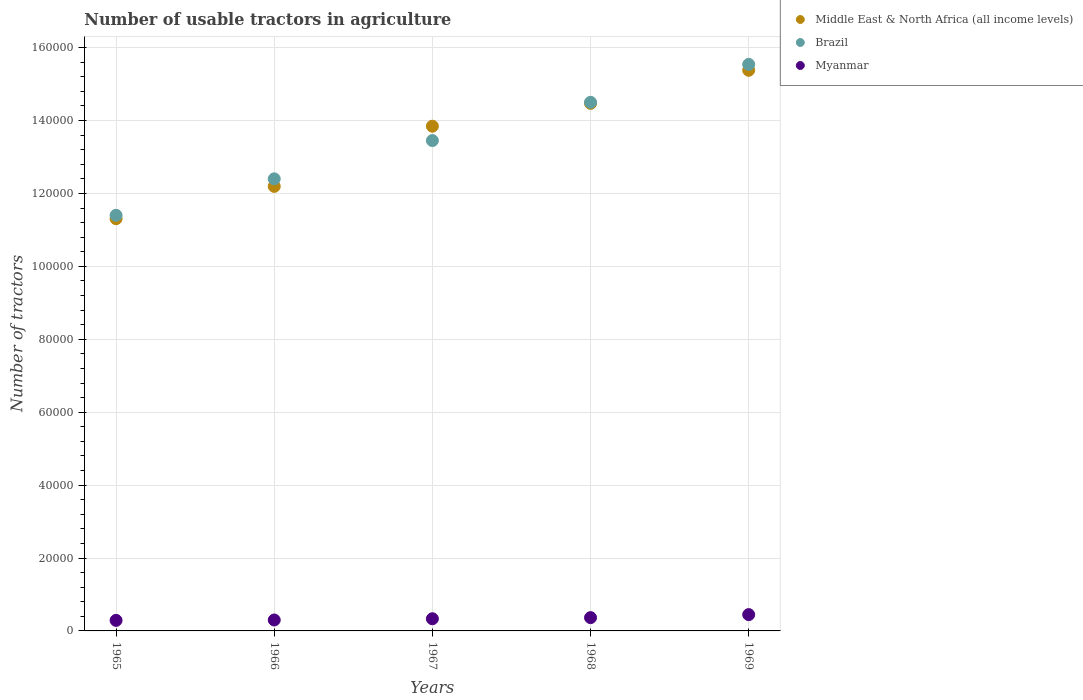What is the number of usable tractors in agriculture in Middle East & North Africa (all income levels) in 1965?
Give a very brief answer. 1.13e+05. Across all years, what is the maximum number of usable tractors in agriculture in Myanmar?
Provide a short and direct response. 4473. Across all years, what is the minimum number of usable tractors in agriculture in Brazil?
Your answer should be compact. 1.14e+05. In which year was the number of usable tractors in agriculture in Brazil maximum?
Make the answer very short. 1969. In which year was the number of usable tractors in agriculture in Middle East & North Africa (all income levels) minimum?
Offer a very short reply. 1965. What is the total number of usable tractors in agriculture in Myanmar in the graph?
Give a very brief answer. 1.73e+04. What is the difference between the number of usable tractors in agriculture in Myanmar in 1966 and that in 1967?
Your response must be concise. -339. What is the difference between the number of usable tractors in agriculture in Brazil in 1969 and the number of usable tractors in agriculture in Middle East & North Africa (all income levels) in 1968?
Ensure brevity in your answer.  1.07e+04. What is the average number of usable tractors in agriculture in Myanmar per year?
Provide a succinct answer. 3469.4. In the year 1968, what is the difference between the number of usable tractors in agriculture in Brazil and number of usable tractors in agriculture in Myanmar?
Provide a succinct answer. 1.41e+05. What is the ratio of the number of usable tractors in agriculture in Brazil in 1966 to that in 1969?
Give a very brief answer. 0.8. Is the number of usable tractors in agriculture in Myanmar in 1965 less than that in 1967?
Make the answer very short. Yes. What is the difference between the highest and the second highest number of usable tractors in agriculture in Brazil?
Your response must be concise. 1.04e+04. What is the difference between the highest and the lowest number of usable tractors in agriculture in Middle East & North Africa (all income levels)?
Keep it short and to the point. 4.07e+04. In how many years, is the number of usable tractors in agriculture in Myanmar greater than the average number of usable tractors in agriculture in Myanmar taken over all years?
Offer a very short reply. 2. Is the sum of the number of usable tractors in agriculture in Brazil in 1967 and 1968 greater than the maximum number of usable tractors in agriculture in Middle East & North Africa (all income levels) across all years?
Provide a succinct answer. Yes. Is the number of usable tractors in agriculture in Myanmar strictly less than the number of usable tractors in agriculture in Middle East & North Africa (all income levels) over the years?
Provide a succinct answer. Yes. How many dotlines are there?
Your answer should be very brief. 3. What is the difference between two consecutive major ticks on the Y-axis?
Keep it short and to the point. 2.00e+04. Does the graph contain any zero values?
Your response must be concise. No. Does the graph contain grids?
Provide a short and direct response. Yes. Where does the legend appear in the graph?
Offer a terse response. Top right. How many legend labels are there?
Your answer should be compact. 3. How are the legend labels stacked?
Offer a very short reply. Vertical. What is the title of the graph?
Make the answer very short. Number of usable tractors in agriculture. What is the label or title of the Y-axis?
Your response must be concise. Number of tractors. What is the Number of tractors in Middle East & North Africa (all income levels) in 1965?
Offer a terse response. 1.13e+05. What is the Number of tractors in Brazil in 1965?
Provide a short and direct response. 1.14e+05. What is the Number of tractors of Myanmar in 1965?
Keep it short and to the point. 2891. What is the Number of tractors of Middle East & North Africa (all income levels) in 1966?
Offer a very short reply. 1.22e+05. What is the Number of tractors of Brazil in 1966?
Your answer should be compact. 1.24e+05. What is the Number of tractors in Myanmar in 1966?
Provide a short and direct response. 3000. What is the Number of tractors of Middle East & North Africa (all income levels) in 1967?
Provide a succinct answer. 1.38e+05. What is the Number of tractors of Brazil in 1967?
Keep it short and to the point. 1.34e+05. What is the Number of tractors in Myanmar in 1967?
Your response must be concise. 3339. What is the Number of tractors of Middle East & North Africa (all income levels) in 1968?
Ensure brevity in your answer.  1.45e+05. What is the Number of tractors in Brazil in 1968?
Make the answer very short. 1.45e+05. What is the Number of tractors of Myanmar in 1968?
Make the answer very short. 3644. What is the Number of tractors in Middle East & North Africa (all income levels) in 1969?
Offer a terse response. 1.54e+05. What is the Number of tractors of Brazil in 1969?
Provide a short and direct response. 1.55e+05. What is the Number of tractors of Myanmar in 1969?
Your answer should be compact. 4473. Across all years, what is the maximum Number of tractors of Middle East & North Africa (all income levels)?
Make the answer very short. 1.54e+05. Across all years, what is the maximum Number of tractors in Brazil?
Offer a very short reply. 1.55e+05. Across all years, what is the maximum Number of tractors in Myanmar?
Offer a very short reply. 4473. Across all years, what is the minimum Number of tractors in Middle East & North Africa (all income levels)?
Give a very brief answer. 1.13e+05. Across all years, what is the minimum Number of tractors of Brazil?
Your answer should be very brief. 1.14e+05. Across all years, what is the minimum Number of tractors in Myanmar?
Keep it short and to the point. 2891. What is the total Number of tractors of Middle East & North Africa (all income levels) in the graph?
Offer a very short reply. 6.72e+05. What is the total Number of tractors in Brazil in the graph?
Provide a succinct answer. 6.73e+05. What is the total Number of tractors of Myanmar in the graph?
Your answer should be very brief. 1.73e+04. What is the difference between the Number of tractors of Middle East & North Africa (all income levels) in 1965 and that in 1966?
Provide a short and direct response. -8868. What is the difference between the Number of tractors in Brazil in 1965 and that in 1966?
Your answer should be very brief. -10000. What is the difference between the Number of tractors in Myanmar in 1965 and that in 1966?
Your answer should be very brief. -109. What is the difference between the Number of tractors of Middle East & North Africa (all income levels) in 1965 and that in 1967?
Your answer should be very brief. -2.54e+04. What is the difference between the Number of tractors in Brazil in 1965 and that in 1967?
Your answer should be very brief. -2.05e+04. What is the difference between the Number of tractors of Myanmar in 1965 and that in 1967?
Offer a terse response. -448. What is the difference between the Number of tractors of Middle East & North Africa (all income levels) in 1965 and that in 1968?
Your response must be concise. -3.16e+04. What is the difference between the Number of tractors in Brazil in 1965 and that in 1968?
Your response must be concise. -3.10e+04. What is the difference between the Number of tractors of Myanmar in 1965 and that in 1968?
Offer a very short reply. -753. What is the difference between the Number of tractors in Middle East & North Africa (all income levels) in 1965 and that in 1969?
Your answer should be compact. -4.07e+04. What is the difference between the Number of tractors in Brazil in 1965 and that in 1969?
Your answer should be compact. -4.14e+04. What is the difference between the Number of tractors in Myanmar in 1965 and that in 1969?
Your response must be concise. -1582. What is the difference between the Number of tractors in Middle East & North Africa (all income levels) in 1966 and that in 1967?
Offer a terse response. -1.65e+04. What is the difference between the Number of tractors in Brazil in 1966 and that in 1967?
Provide a short and direct response. -1.05e+04. What is the difference between the Number of tractors of Myanmar in 1966 and that in 1967?
Provide a short and direct response. -339. What is the difference between the Number of tractors of Middle East & North Africa (all income levels) in 1966 and that in 1968?
Your answer should be compact. -2.28e+04. What is the difference between the Number of tractors of Brazil in 1966 and that in 1968?
Your response must be concise. -2.10e+04. What is the difference between the Number of tractors of Myanmar in 1966 and that in 1968?
Your answer should be very brief. -644. What is the difference between the Number of tractors of Middle East & North Africa (all income levels) in 1966 and that in 1969?
Keep it short and to the point. -3.18e+04. What is the difference between the Number of tractors in Brazil in 1966 and that in 1969?
Make the answer very short. -3.14e+04. What is the difference between the Number of tractors of Myanmar in 1966 and that in 1969?
Make the answer very short. -1473. What is the difference between the Number of tractors of Middle East & North Africa (all income levels) in 1967 and that in 1968?
Offer a very short reply. -6269. What is the difference between the Number of tractors of Brazil in 1967 and that in 1968?
Make the answer very short. -1.05e+04. What is the difference between the Number of tractors of Myanmar in 1967 and that in 1968?
Offer a terse response. -305. What is the difference between the Number of tractors in Middle East & North Africa (all income levels) in 1967 and that in 1969?
Your answer should be very brief. -1.53e+04. What is the difference between the Number of tractors of Brazil in 1967 and that in 1969?
Provide a succinct answer. -2.09e+04. What is the difference between the Number of tractors in Myanmar in 1967 and that in 1969?
Provide a succinct answer. -1134. What is the difference between the Number of tractors in Middle East & North Africa (all income levels) in 1968 and that in 1969?
Offer a terse response. -9075. What is the difference between the Number of tractors of Brazil in 1968 and that in 1969?
Give a very brief answer. -1.04e+04. What is the difference between the Number of tractors of Myanmar in 1968 and that in 1969?
Give a very brief answer. -829. What is the difference between the Number of tractors in Middle East & North Africa (all income levels) in 1965 and the Number of tractors in Brazil in 1966?
Keep it short and to the point. -1.09e+04. What is the difference between the Number of tractors in Middle East & North Africa (all income levels) in 1965 and the Number of tractors in Myanmar in 1966?
Provide a short and direct response. 1.10e+05. What is the difference between the Number of tractors of Brazil in 1965 and the Number of tractors of Myanmar in 1966?
Your response must be concise. 1.11e+05. What is the difference between the Number of tractors of Middle East & North Africa (all income levels) in 1965 and the Number of tractors of Brazil in 1967?
Your answer should be very brief. -2.14e+04. What is the difference between the Number of tractors of Middle East & North Africa (all income levels) in 1965 and the Number of tractors of Myanmar in 1967?
Offer a very short reply. 1.10e+05. What is the difference between the Number of tractors in Brazil in 1965 and the Number of tractors in Myanmar in 1967?
Your answer should be very brief. 1.11e+05. What is the difference between the Number of tractors of Middle East & North Africa (all income levels) in 1965 and the Number of tractors of Brazil in 1968?
Provide a short and direct response. -3.19e+04. What is the difference between the Number of tractors of Middle East & North Africa (all income levels) in 1965 and the Number of tractors of Myanmar in 1968?
Provide a succinct answer. 1.09e+05. What is the difference between the Number of tractors of Brazil in 1965 and the Number of tractors of Myanmar in 1968?
Provide a succinct answer. 1.10e+05. What is the difference between the Number of tractors of Middle East & North Africa (all income levels) in 1965 and the Number of tractors of Brazil in 1969?
Make the answer very short. -4.23e+04. What is the difference between the Number of tractors in Middle East & North Africa (all income levels) in 1965 and the Number of tractors in Myanmar in 1969?
Your response must be concise. 1.09e+05. What is the difference between the Number of tractors of Brazil in 1965 and the Number of tractors of Myanmar in 1969?
Keep it short and to the point. 1.10e+05. What is the difference between the Number of tractors of Middle East & North Africa (all income levels) in 1966 and the Number of tractors of Brazil in 1967?
Ensure brevity in your answer.  -1.26e+04. What is the difference between the Number of tractors of Middle East & North Africa (all income levels) in 1966 and the Number of tractors of Myanmar in 1967?
Keep it short and to the point. 1.19e+05. What is the difference between the Number of tractors of Brazil in 1966 and the Number of tractors of Myanmar in 1967?
Offer a very short reply. 1.21e+05. What is the difference between the Number of tractors in Middle East & North Africa (all income levels) in 1966 and the Number of tractors in Brazil in 1968?
Your answer should be compact. -2.31e+04. What is the difference between the Number of tractors in Middle East & North Africa (all income levels) in 1966 and the Number of tractors in Myanmar in 1968?
Your answer should be compact. 1.18e+05. What is the difference between the Number of tractors of Brazil in 1966 and the Number of tractors of Myanmar in 1968?
Offer a very short reply. 1.20e+05. What is the difference between the Number of tractors of Middle East & North Africa (all income levels) in 1966 and the Number of tractors of Brazil in 1969?
Make the answer very short. -3.35e+04. What is the difference between the Number of tractors in Middle East & North Africa (all income levels) in 1966 and the Number of tractors in Myanmar in 1969?
Provide a short and direct response. 1.17e+05. What is the difference between the Number of tractors of Brazil in 1966 and the Number of tractors of Myanmar in 1969?
Provide a short and direct response. 1.20e+05. What is the difference between the Number of tractors of Middle East & North Africa (all income levels) in 1967 and the Number of tractors of Brazil in 1968?
Ensure brevity in your answer.  -6561. What is the difference between the Number of tractors in Middle East & North Africa (all income levels) in 1967 and the Number of tractors in Myanmar in 1968?
Provide a short and direct response. 1.35e+05. What is the difference between the Number of tractors in Brazil in 1967 and the Number of tractors in Myanmar in 1968?
Provide a succinct answer. 1.31e+05. What is the difference between the Number of tractors in Middle East & North Africa (all income levels) in 1967 and the Number of tractors in Brazil in 1969?
Provide a short and direct response. -1.70e+04. What is the difference between the Number of tractors in Middle East & North Africa (all income levels) in 1967 and the Number of tractors in Myanmar in 1969?
Your response must be concise. 1.34e+05. What is the difference between the Number of tractors in Brazil in 1967 and the Number of tractors in Myanmar in 1969?
Provide a short and direct response. 1.30e+05. What is the difference between the Number of tractors of Middle East & North Africa (all income levels) in 1968 and the Number of tractors of Brazil in 1969?
Make the answer very short. -1.07e+04. What is the difference between the Number of tractors in Middle East & North Africa (all income levels) in 1968 and the Number of tractors in Myanmar in 1969?
Give a very brief answer. 1.40e+05. What is the difference between the Number of tractors of Brazil in 1968 and the Number of tractors of Myanmar in 1969?
Your answer should be very brief. 1.41e+05. What is the average Number of tractors of Middle East & North Africa (all income levels) per year?
Your response must be concise. 1.34e+05. What is the average Number of tractors of Brazil per year?
Provide a short and direct response. 1.35e+05. What is the average Number of tractors of Myanmar per year?
Ensure brevity in your answer.  3469.4. In the year 1965, what is the difference between the Number of tractors in Middle East & North Africa (all income levels) and Number of tractors in Brazil?
Offer a very short reply. -932. In the year 1965, what is the difference between the Number of tractors of Middle East & North Africa (all income levels) and Number of tractors of Myanmar?
Offer a very short reply. 1.10e+05. In the year 1965, what is the difference between the Number of tractors in Brazil and Number of tractors in Myanmar?
Provide a succinct answer. 1.11e+05. In the year 1966, what is the difference between the Number of tractors of Middle East & North Africa (all income levels) and Number of tractors of Brazil?
Ensure brevity in your answer.  -2064. In the year 1966, what is the difference between the Number of tractors in Middle East & North Africa (all income levels) and Number of tractors in Myanmar?
Ensure brevity in your answer.  1.19e+05. In the year 1966, what is the difference between the Number of tractors of Brazil and Number of tractors of Myanmar?
Your answer should be compact. 1.21e+05. In the year 1967, what is the difference between the Number of tractors in Middle East & North Africa (all income levels) and Number of tractors in Brazil?
Provide a short and direct response. 3939. In the year 1967, what is the difference between the Number of tractors in Middle East & North Africa (all income levels) and Number of tractors in Myanmar?
Offer a terse response. 1.35e+05. In the year 1967, what is the difference between the Number of tractors of Brazil and Number of tractors of Myanmar?
Provide a succinct answer. 1.31e+05. In the year 1968, what is the difference between the Number of tractors of Middle East & North Africa (all income levels) and Number of tractors of Brazil?
Your answer should be compact. -292. In the year 1968, what is the difference between the Number of tractors in Middle East & North Africa (all income levels) and Number of tractors in Myanmar?
Provide a succinct answer. 1.41e+05. In the year 1968, what is the difference between the Number of tractors of Brazil and Number of tractors of Myanmar?
Your answer should be compact. 1.41e+05. In the year 1969, what is the difference between the Number of tractors in Middle East & North Africa (all income levels) and Number of tractors in Brazil?
Offer a very short reply. -1617. In the year 1969, what is the difference between the Number of tractors in Middle East & North Africa (all income levels) and Number of tractors in Myanmar?
Provide a short and direct response. 1.49e+05. In the year 1969, what is the difference between the Number of tractors in Brazil and Number of tractors in Myanmar?
Your answer should be compact. 1.51e+05. What is the ratio of the Number of tractors of Middle East & North Africa (all income levels) in 1965 to that in 1966?
Make the answer very short. 0.93. What is the ratio of the Number of tractors in Brazil in 1965 to that in 1966?
Ensure brevity in your answer.  0.92. What is the ratio of the Number of tractors of Myanmar in 1965 to that in 1966?
Give a very brief answer. 0.96. What is the ratio of the Number of tractors of Middle East & North Africa (all income levels) in 1965 to that in 1967?
Make the answer very short. 0.82. What is the ratio of the Number of tractors of Brazil in 1965 to that in 1967?
Offer a very short reply. 0.85. What is the ratio of the Number of tractors in Myanmar in 1965 to that in 1967?
Give a very brief answer. 0.87. What is the ratio of the Number of tractors in Middle East & North Africa (all income levels) in 1965 to that in 1968?
Give a very brief answer. 0.78. What is the ratio of the Number of tractors of Brazil in 1965 to that in 1968?
Offer a terse response. 0.79. What is the ratio of the Number of tractors of Myanmar in 1965 to that in 1968?
Offer a very short reply. 0.79. What is the ratio of the Number of tractors of Middle East & North Africa (all income levels) in 1965 to that in 1969?
Your answer should be very brief. 0.74. What is the ratio of the Number of tractors in Brazil in 1965 to that in 1969?
Keep it short and to the point. 0.73. What is the ratio of the Number of tractors of Myanmar in 1965 to that in 1969?
Offer a very short reply. 0.65. What is the ratio of the Number of tractors of Middle East & North Africa (all income levels) in 1966 to that in 1967?
Your answer should be compact. 0.88. What is the ratio of the Number of tractors in Brazil in 1966 to that in 1967?
Keep it short and to the point. 0.92. What is the ratio of the Number of tractors of Myanmar in 1966 to that in 1967?
Provide a short and direct response. 0.9. What is the ratio of the Number of tractors of Middle East & North Africa (all income levels) in 1966 to that in 1968?
Keep it short and to the point. 0.84. What is the ratio of the Number of tractors of Brazil in 1966 to that in 1968?
Make the answer very short. 0.86. What is the ratio of the Number of tractors of Myanmar in 1966 to that in 1968?
Your answer should be compact. 0.82. What is the ratio of the Number of tractors of Middle East & North Africa (all income levels) in 1966 to that in 1969?
Offer a very short reply. 0.79. What is the ratio of the Number of tractors of Brazil in 1966 to that in 1969?
Give a very brief answer. 0.8. What is the ratio of the Number of tractors of Myanmar in 1966 to that in 1969?
Provide a succinct answer. 0.67. What is the ratio of the Number of tractors of Middle East & North Africa (all income levels) in 1967 to that in 1968?
Keep it short and to the point. 0.96. What is the ratio of the Number of tractors of Brazil in 1967 to that in 1968?
Ensure brevity in your answer.  0.93. What is the ratio of the Number of tractors of Myanmar in 1967 to that in 1968?
Provide a succinct answer. 0.92. What is the ratio of the Number of tractors in Middle East & North Africa (all income levels) in 1967 to that in 1969?
Offer a terse response. 0.9. What is the ratio of the Number of tractors in Brazil in 1967 to that in 1969?
Offer a very short reply. 0.87. What is the ratio of the Number of tractors of Myanmar in 1967 to that in 1969?
Make the answer very short. 0.75. What is the ratio of the Number of tractors of Middle East & North Africa (all income levels) in 1968 to that in 1969?
Your answer should be very brief. 0.94. What is the ratio of the Number of tractors in Brazil in 1968 to that in 1969?
Provide a succinct answer. 0.93. What is the ratio of the Number of tractors in Myanmar in 1968 to that in 1969?
Ensure brevity in your answer.  0.81. What is the difference between the highest and the second highest Number of tractors in Middle East & North Africa (all income levels)?
Your answer should be very brief. 9075. What is the difference between the highest and the second highest Number of tractors in Brazil?
Give a very brief answer. 1.04e+04. What is the difference between the highest and the second highest Number of tractors in Myanmar?
Provide a short and direct response. 829. What is the difference between the highest and the lowest Number of tractors of Middle East & North Africa (all income levels)?
Keep it short and to the point. 4.07e+04. What is the difference between the highest and the lowest Number of tractors in Brazil?
Provide a succinct answer. 4.14e+04. What is the difference between the highest and the lowest Number of tractors in Myanmar?
Your response must be concise. 1582. 